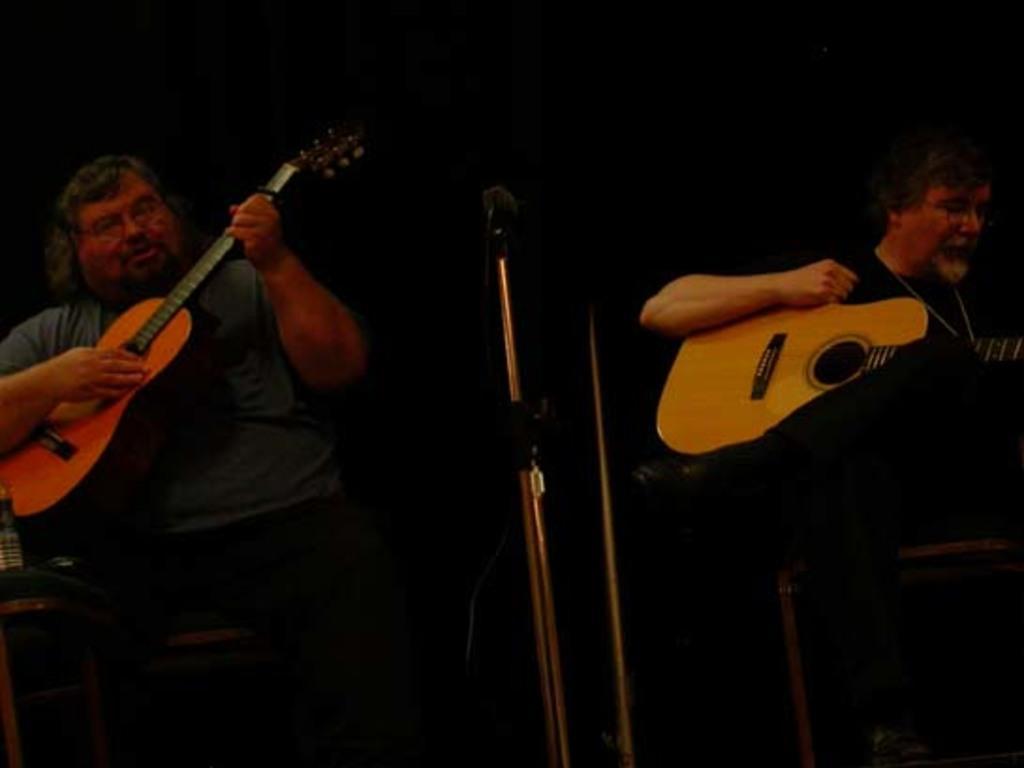Could you give a brief overview of what you see in this image? In the picture there are two person sitting and playing guitar there is a microphone and front of them. 